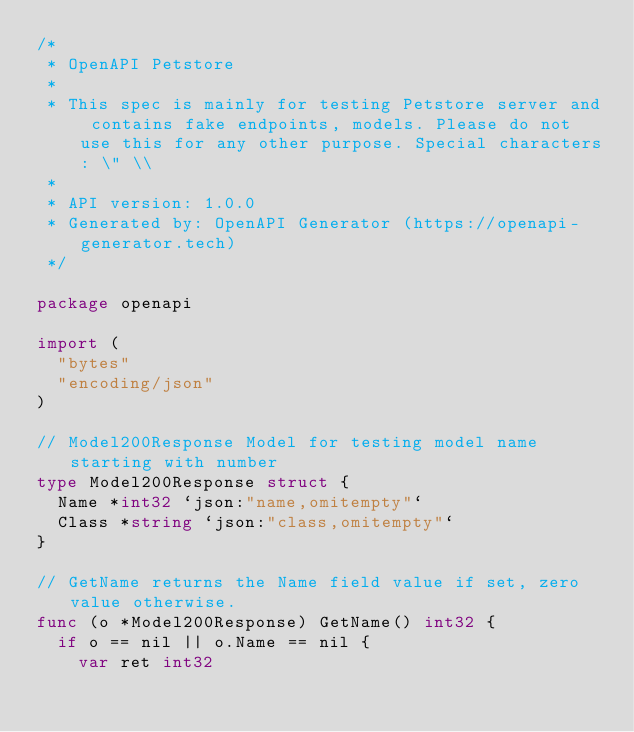<code> <loc_0><loc_0><loc_500><loc_500><_Go_>/*
 * OpenAPI Petstore
 *
 * This spec is mainly for testing Petstore server and contains fake endpoints, models. Please do not use this for any other purpose. Special characters: \" \\
 *
 * API version: 1.0.0
 * Generated by: OpenAPI Generator (https://openapi-generator.tech)
 */

package openapi

import (
	"bytes"
	"encoding/json"
)

// Model200Response Model for testing model name starting with number
type Model200Response struct {
	Name *int32 `json:"name,omitempty"`
	Class *string `json:"class,omitempty"`
}

// GetName returns the Name field value if set, zero value otherwise.
func (o *Model200Response) GetName() int32 {
	if o == nil || o.Name == nil {
		var ret int32</code> 